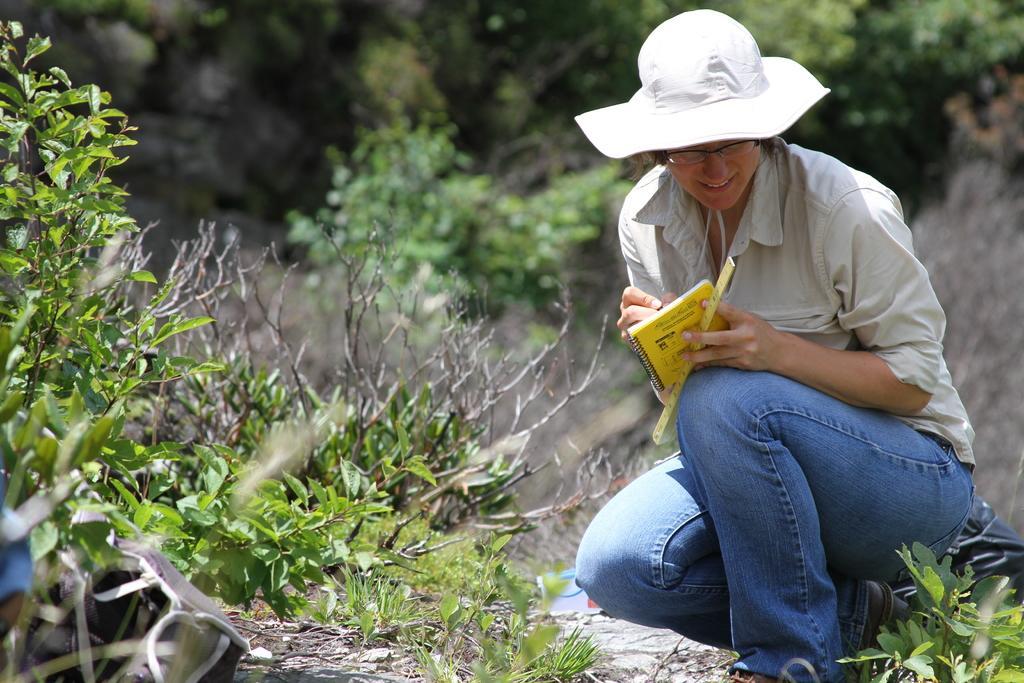Describe this image in one or two sentences. On the we can see a plant and a woman. On the left there are plants. The background is blurred. In the background there is greenery. 